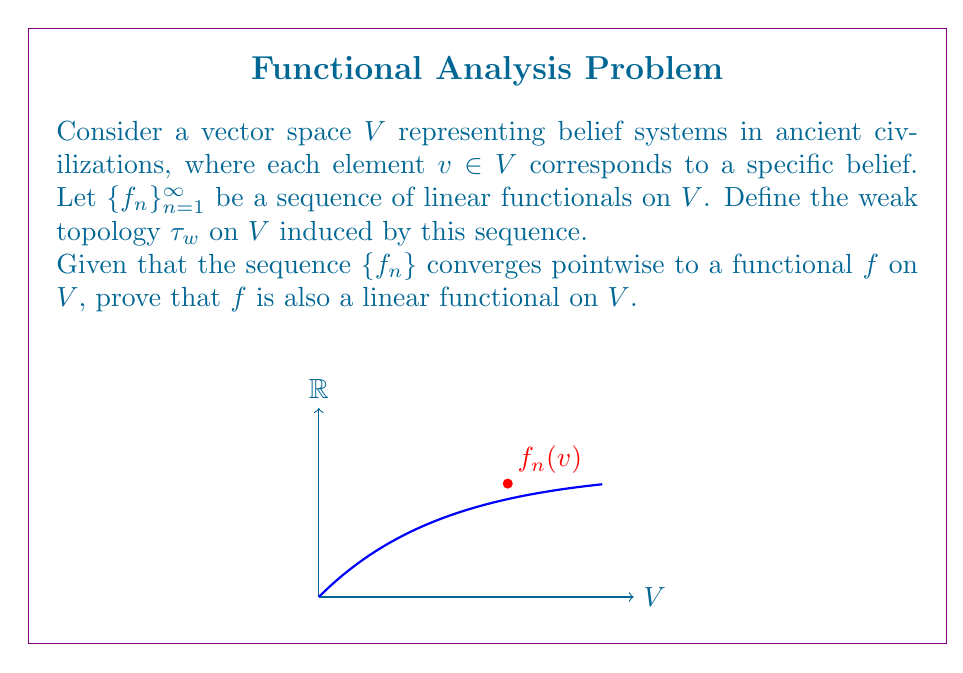Could you help me with this problem? Let's approach this proof step-by-step:

1) First, recall that a functional $f$ is linear if it satisfies two properties for all $u,v \in V$ and scalars $\alpha$:
   a) $f(u + v) = f(u) + f(v)$ (additivity)
   b) $f(\alpha v) = \alpha f(v)$ (homogeneity)

2) We are given that $\{f_n\}$ converges pointwise to $f$. This means:
   $$\lim_{n \to \infty} f_n(v) = f(v) \quad \forall v \in V$$

3) To prove additivity:
   Let $u, v \in V$. We need to show $f(u + v) = f(u) + f(v)$.
   $$\begin{align}
   f(u + v) &= \lim_{n \to \infty} f_n(u + v) \\
            &= \lim_{n \to \infty} (f_n(u) + f_n(v)) \quad \text{(since each $f_n$ is linear)} \\
            &= \lim_{n \to \infty} f_n(u) + \lim_{n \to \infty} f_n(v) \\
            &= f(u) + f(v)
   \end{align}$$

4) To prove homogeneity:
   Let $v \in V$ and $\alpha$ be a scalar. We need to show $f(\alpha v) = \alpha f(v)$.
   $$\begin{align}
   f(\alpha v) &= \lim_{n \to \infty} f_n(\alpha v) \\
               &= \lim_{n \to \infty} \alpha f_n(v) \quad \text{(since each $f_n$ is linear)} \\
               &= \alpha \lim_{n \to \infty} f_n(v) \\
               &= \alpha f(v)
   \end{align}$$

5) Since both additivity and homogeneity are satisfied, $f$ is indeed a linear functional on $V$.

This proof demonstrates that the limit of linear functionals in the weak topology preserves linearity, which is crucial when studying the structure of belief systems in ancient civilizations through a functional analysis lens.
Answer: $f$ is a linear functional on $V$. 